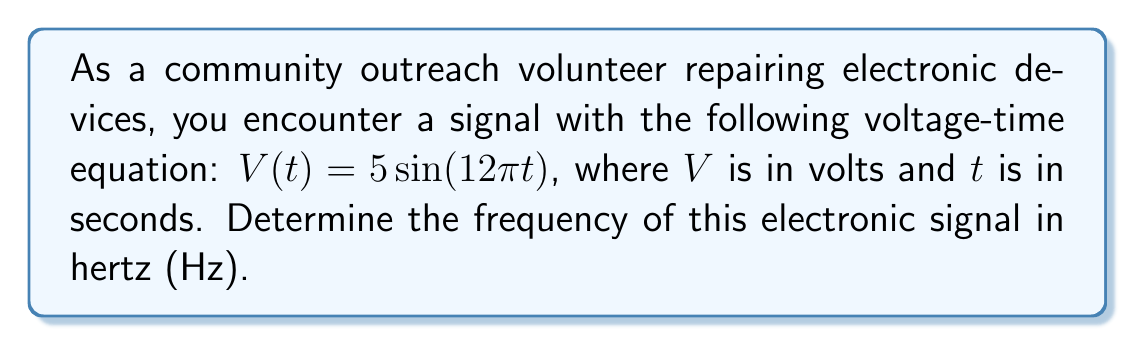What is the answer to this math problem? Let's approach this step-by-step:

1) The general form of a sinusoidal function is:
   $$V(t) = A\sin(2\pi ft + \phi)$$
   where $A$ is the amplitude, $f$ is the frequency in Hz, and $\phi$ is the phase shift.

2) Comparing our given equation to the general form:
   $$5\sin(12\pi t) = 5\sin(2\pi ft)$$

3) We can see that the amplitude $A = 5$, but we're more interested in the frequency.

4) In the general form, the argument of the sine function is $2\pi ft$.
   In our equation, it's $12\pi t$.

5) Therefore:
   $$2\pi ft = 12\pi t$$

6) Dividing both sides by $2\pi t$:
   $$f = \frac{12\pi t}{2\pi t} = \frac{12\pi}{2\pi} = 6$$

7) Thus, the frequency $f$ is 6 Hz.
Answer: 6 Hz 